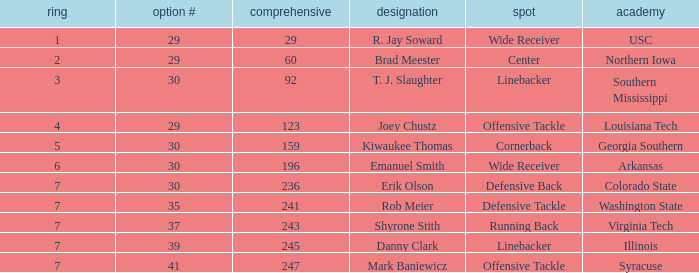What is the Position with a round 3 pick for r. jay soward? Wide Receiver. 